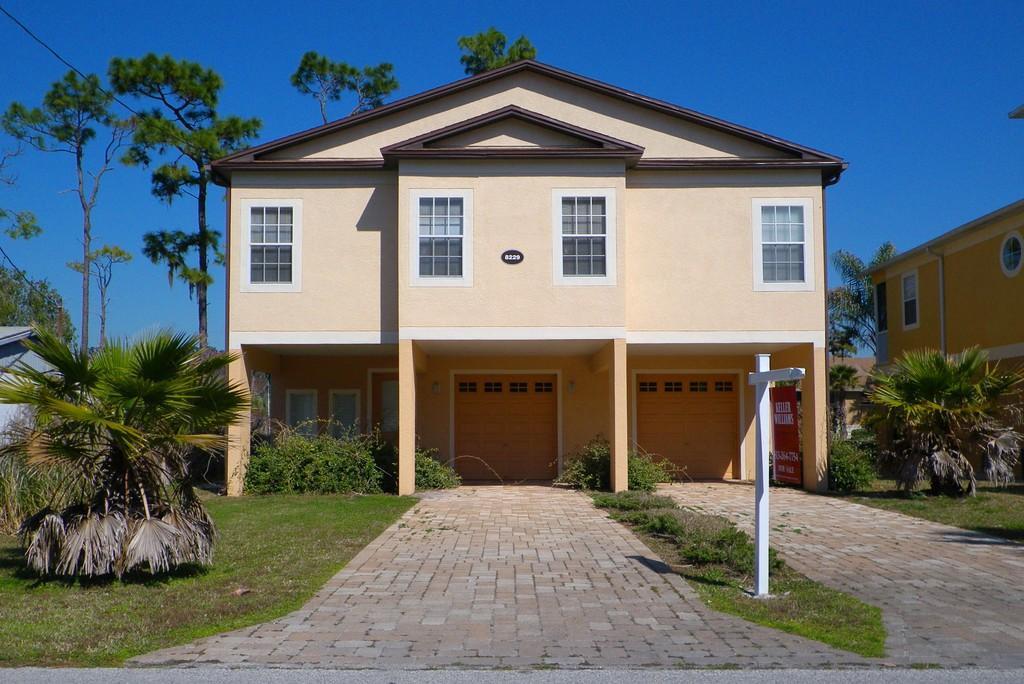How would you summarize this image in a sentence or two? In this image we can see some houses with windows and a roof. We can also see some plants, grass, a pathway and a sign board to a pole. On the backside we can see some trees and the sky which looks cloudy. 